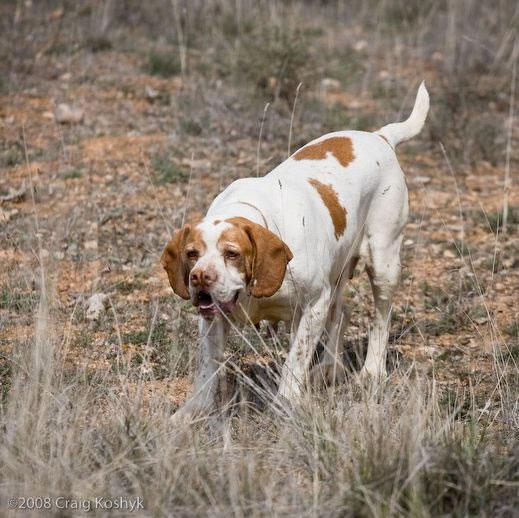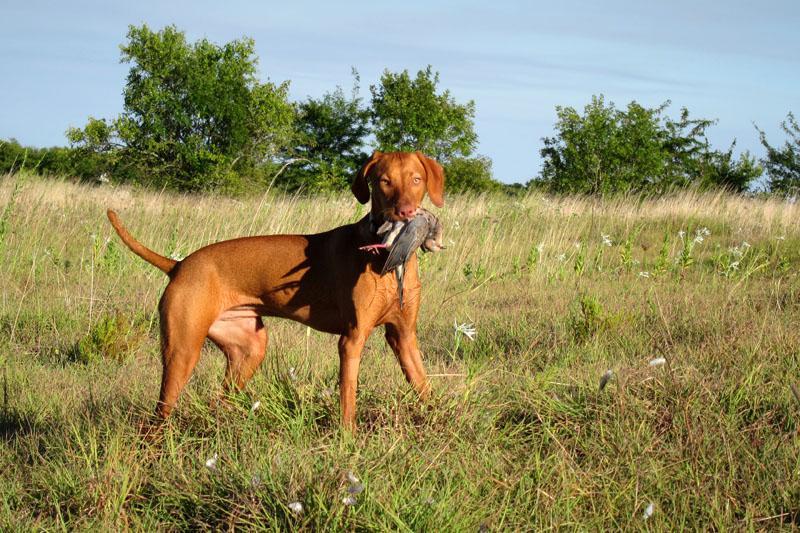The first image is the image on the left, the second image is the image on the right. Evaluate the accuracy of this statement regarding the images: "There are three dogs looking attentively forward.". Is it true? Answer yes or no. No. The first image is the image on the left, the second image is the image on the right. Assess this claim about the two images: "At least three dogs are sitting nicely in one of the pictures.". Correct or not? Answer yes or no. No. 